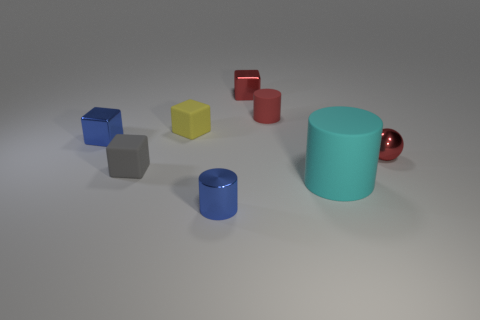Add 1 small red metallic cubes. How many objects exist? 9 Subtract all cylinders. How many objects are left? 5 Subtract all small cylinders. Subtract all tiny yellow rubber cubes. How many objects are left? 5 Add 7 large cyan cylinders. How many large cyan cylinders are left? 8 Add 7 cyan cylinders. How many cyan cylinders exist? 8 Subtract 1 red balls. How many objects are left? 7 